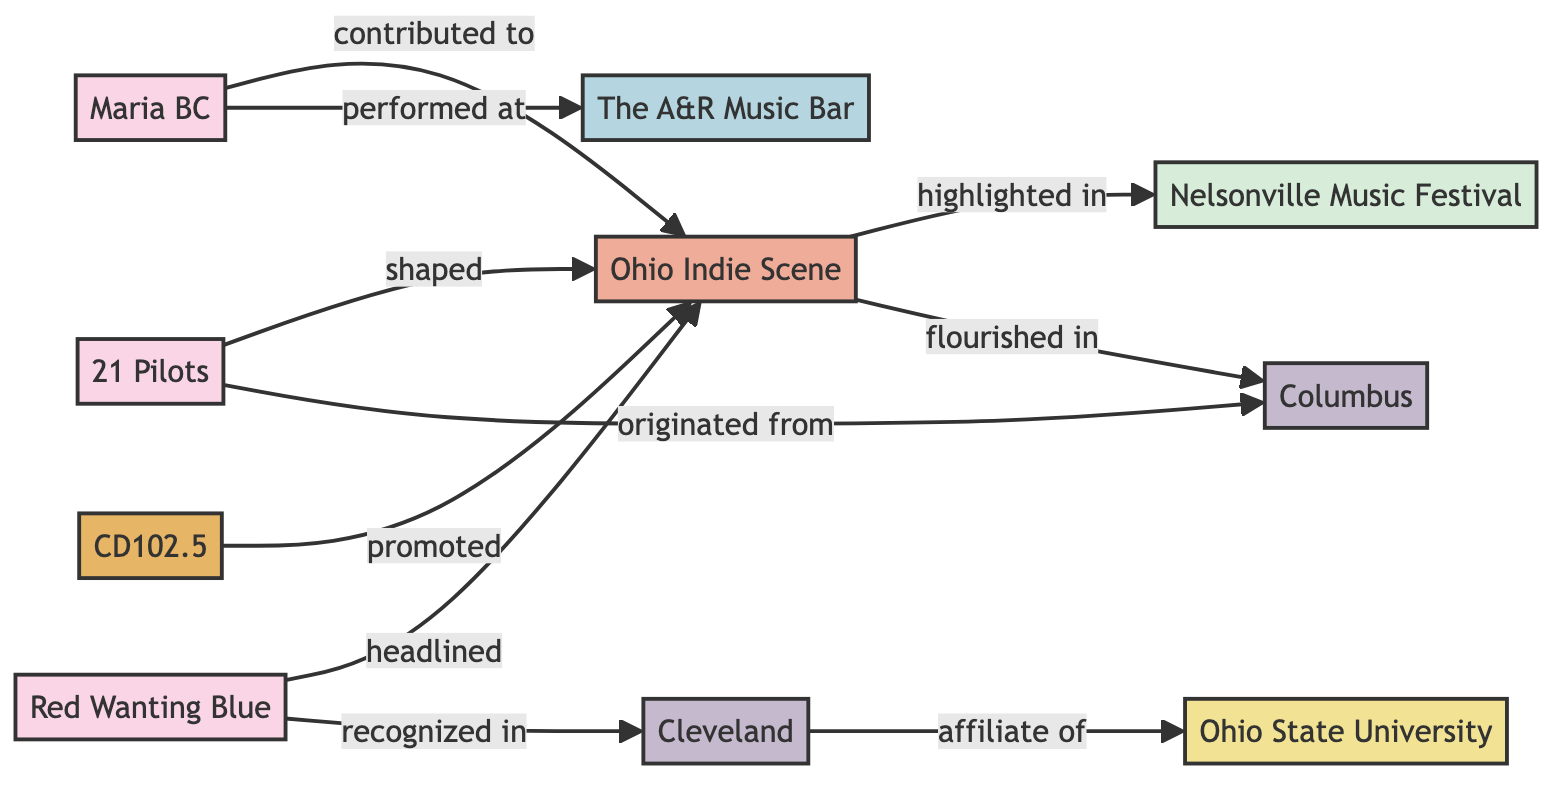What artists are connected to the Ohio Indie Scene? The Ohio Indie Scene has connections to Maria BC, 21 Pilots, and Red Wanting Blue. These connections are established through edges labeled "contributed to," "shaped," and "headlined," respectively.
Answer: Maria BC, 21 Pilots, Red Wanting Blue How many nodes are in the diagram? The diagram includes 10 distinct nodes, which are represented by artists, scenes, radio, festivals, venues, cities, and institutions.
Answer: 10 What city did 21 Pilots originate from? The diagram states that 21 Pilots has an edge that indicates they originated from Columbus, identified by the directed edge labeled "originated from."
Answer: Columbus Which festival is highlighted in the Ohio Indie Scene? The directed edge shows that the Ohio Indie Scene is highlighted in the Nelsonville Music Festival, indicated by the edge labeled "highlighted in."
Answer: Nelsonville Music Festival Which cities are involved in this diagram? The diagram features two cities connected to the music scene: Columbus and Cleveland, as shown through their respective edges connected to the Ohio Indie Scene and Red Wanting Blue.
Answer: Columbus, Cleveland How many edges connect artists to the Ohio Indie Scene? There are three edges connecting different artists to the Ohio Indie Scene, specifically from Maria BC, 21 Pilots, and Red Wanting Blue, emphasizing their contributions.
Answer: 3 What is the relationship between Cleveland and Ohio State University? The directed edge shows that Cleveland is an affiliate of Ohio State University, indicating a connection in their respective roles within the context of the local music scene.
Answer: affiliate of What role does CD102.5 play in the Ohio Indie Scene? CD102.5 is indicated by an edge that shows it promotes the Ohio Indie Scene, establishing its supportive role within the local music network.
Answer: promoted Which venue did Maria BC perform at? The diagram specifies that Maria BC performed at The A&R Music Bar, as shown by the directed edge from Maria BC to the venue.
Answer: The A&R Music Bar 